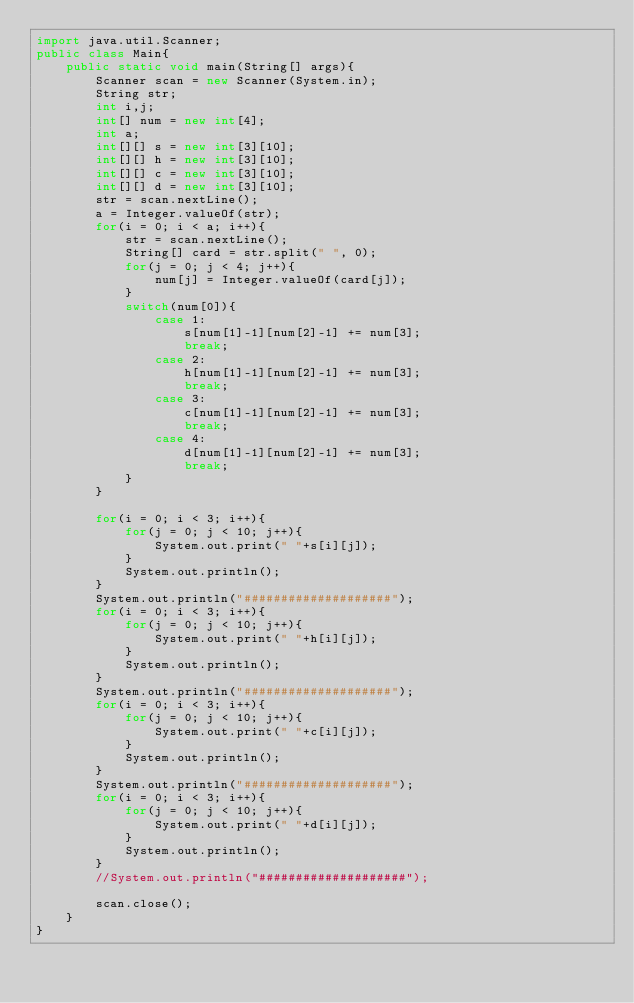<code> <loc_0><loc_0><loc_500><loc_500><_Java_>import java.util.Scanner;
public class Main{
    public static void main(String[] args){
        Scanner scan = new Scanner(System.in);
        String str;
        int i,j;
        int[] num = new int[4];
        int a;
        int[][] s = new int[3][10];
        int[][] h = new int[3][10];
        int[][] c = new int[3][10];
        int[][] d = new int[3][10];
        str = scan.nextLine();
        a = Integer.valueOf(str);
        for(i = 0; i < a; i++){
            str = scan.nextLine();
            String[] card = str.split(" ", 0);
            for(j = 0; j < 4; j++){
                num[j] = Integer.valueOf(card[j]);
            }
            switch(num[0]){
                case 1:
                    s[num[1]-1][num[2]-1] += num[3];
                    break;
                case 2:
                    h[num[1]-1][num[2]-1] += num[3];
                    break;
                case 3:
                    c[num[1]-1][num[2]-1] += num[3];
                    break;
                case 4:
                    d[num[1]-1][num[2]-1] += num[3];
                    break;
            }
        }

        for(i = 0; i < 3; i++){
            for(j = 0; j < 10; j++){
                System.out.print(" "+s[i][j]);
            }
            System.out.println();
        }
        System.out.println("####################");
        for(i = 0; i < 3; i++){
            for(j = 0; j < 10; j++){
                System.out.print(" "+h[i][j]);
            }
            System.out.println();
        }
        System.out.println("####################");
        for(i = 0; i < 3; i++){
            for(j = 0; j < 10; j++){
                System.out.print(" "+c[i][j]);
            }
            System.out.println();
        }
        System.out.println("####################");
        for(i = 0; i < 3; i++){
            for(j = 0; j < 10; j++){
                System.out.print(" "+d[i][j]);
            }
            System.out.println();
        }
        //System.out.println("####################");
        
        scan.close();
    }
}
</code> 